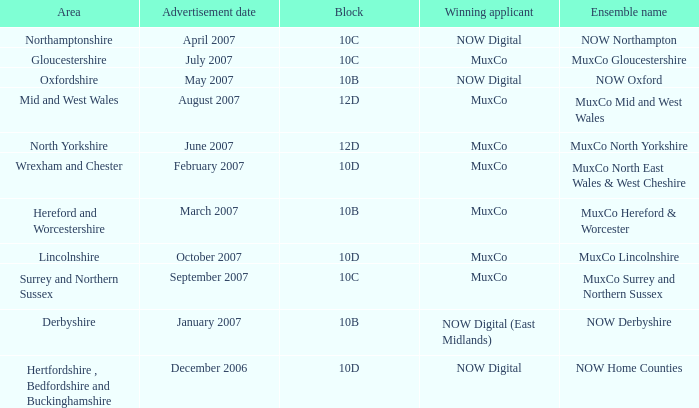What is Oxfordshire Area's Ensemble Name? NOW Oxford. 